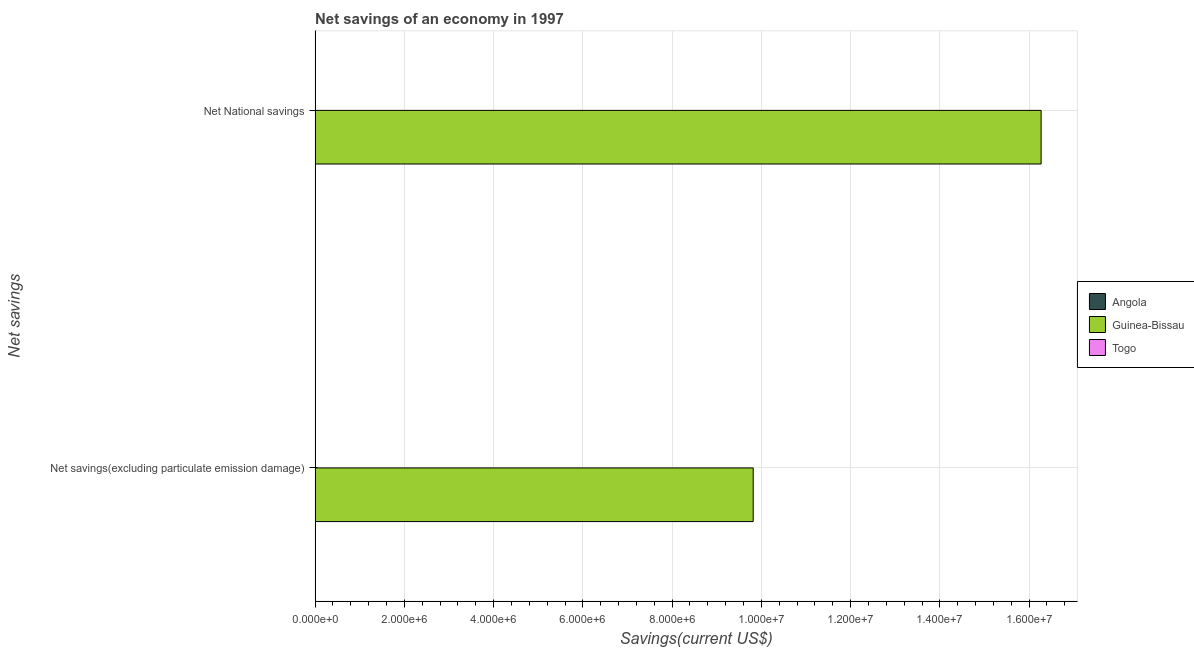Are the number of bars per tick equal to the number of legend labels?
Make the answer very short. No. Are the number of bars on each tick of the Y-axis equal?
Provide a succinct answer. Yes. How many bars are there on the 1st tick from the top?
Provide a short and direct response. 1. What is the label of the 2nd group of bars from the top?
Keep it short and to the point. Net savings(excluding particulate emission damage). What is the net national savings in Guinea-Bissau?
Give a very brief answer. 1.63e+07. Across all countries, what is the maximum net savings(excluding particulate emission damage)?
Ensure brevity in your answer.  9.82e+06. In which country was the net savings(excluding particulate emission damage) maximum?
Offer a very short reply. Guinea-Bissau. What is the total net savings(excluding particulate emission damage) in the graph?
Your response must be concise. 9.82e+06. What is the difference between the net national savings in Guinea-Bissau and the net savings(excluding particulate emission damage) in Togo?
Your answer should be compact. 1.63e+07. What is the average net savings(excluding particulate emission damage) per country?
Offer a very short reply. 3.27e+06. What is the difference between the net savings(excluding particulate emission damage) and net national savings in Guinea-Bissau?
Keep it short and to the point. -6.45e+06. In how many countries, is the net savings(excluding particulate emission damage) greater than the average net savings(excluding particulate emission damage) taken over all countries?
Offer a terse response. 1. What is the difference between two consecutive major ticks on the X-axis?
Your response must be concise. 2.00e+06. Does the graph contain any zero values?
Keep it short and to the point. Yes. Where does the legend appear in the graph?
Ensure brevity in your answer.  Center right. How many legend labels are there?
Offer a very short reply. 3. What is the title of the graph?
Give a very brief answer. Net savings of an economy in 1997. What is the label or title of the X-axis?
Offer a very short reply. Savings(current US$). What is the label or title of the Y-axis?
Provide a short and direct response. Net savings. What is the Savings(current US$) of Guinea-Bissau in Net savings(excluding particulate emission damage)?
Your answer should be compact. 9.82e+06. What is the Savings(current US$) in Togo in Net savings(excluding particulate emission damage)?
Provide a succinct answer. 0. What is the Savings(current US$) in Guinea-Bissau in Net National savings?
Your response must be concise. 1.63e+07. Across all Net savings, what is the maximum Savings(current US$) of Guinea-Bissau?
Offer a very short reply. 1.63e+07. Across all Net savings, what is the minimum Savings(current US$) in Guinea-Bissau?
Provide a succinct answer. 9.82e+06. What is the total Savings(current US$) in Guinea-Bissau in the graph?
Make the answer very short. 2.61e+07. What is the difference between the Savings(current US$) in Guinea-Bissau in Net savings(excluding particulate emission damage) and that in Net National savings?
Ensure brevity in your answer.  -6.45e+06. What is the average Savings(current US$) of Angola per Net savings?
Offer a terse response. 0. What is the average Savings(current US$) of Guinea-Bissau per Net savings?
Keep it short and to the point. 1.30e+07. What is the ratio of the Savings(current US$) of Guinea-Bissau in Net savings(excluding particulate emission damage) to that in Net National savings?
Offer a terse response. 0.6. What is the difference between the highest and the second highest Savings(current US$) of Guinea-Bissau?
Offer a terse response. 6.45e+06. What is the difference between the highest and the lowest Savings(current US$) in Guinea-Bissau?
Keep it short and to the point. 6.45e+06. 